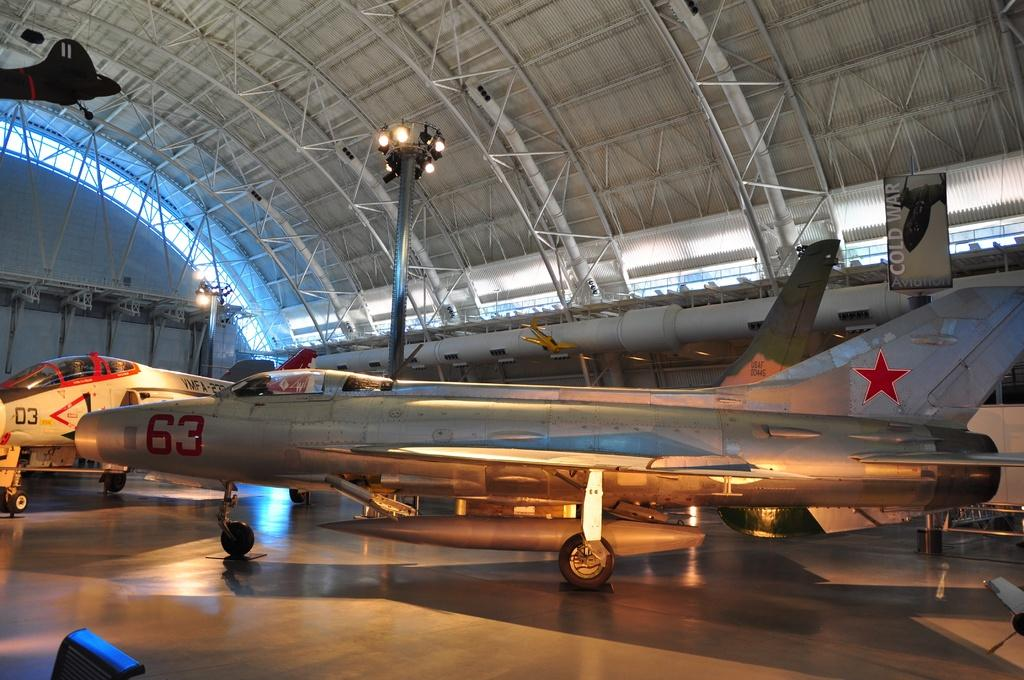<image>
Create a compact narrative representing the image presented. mant airplanes are inside a large building including a silver one with the number 63 